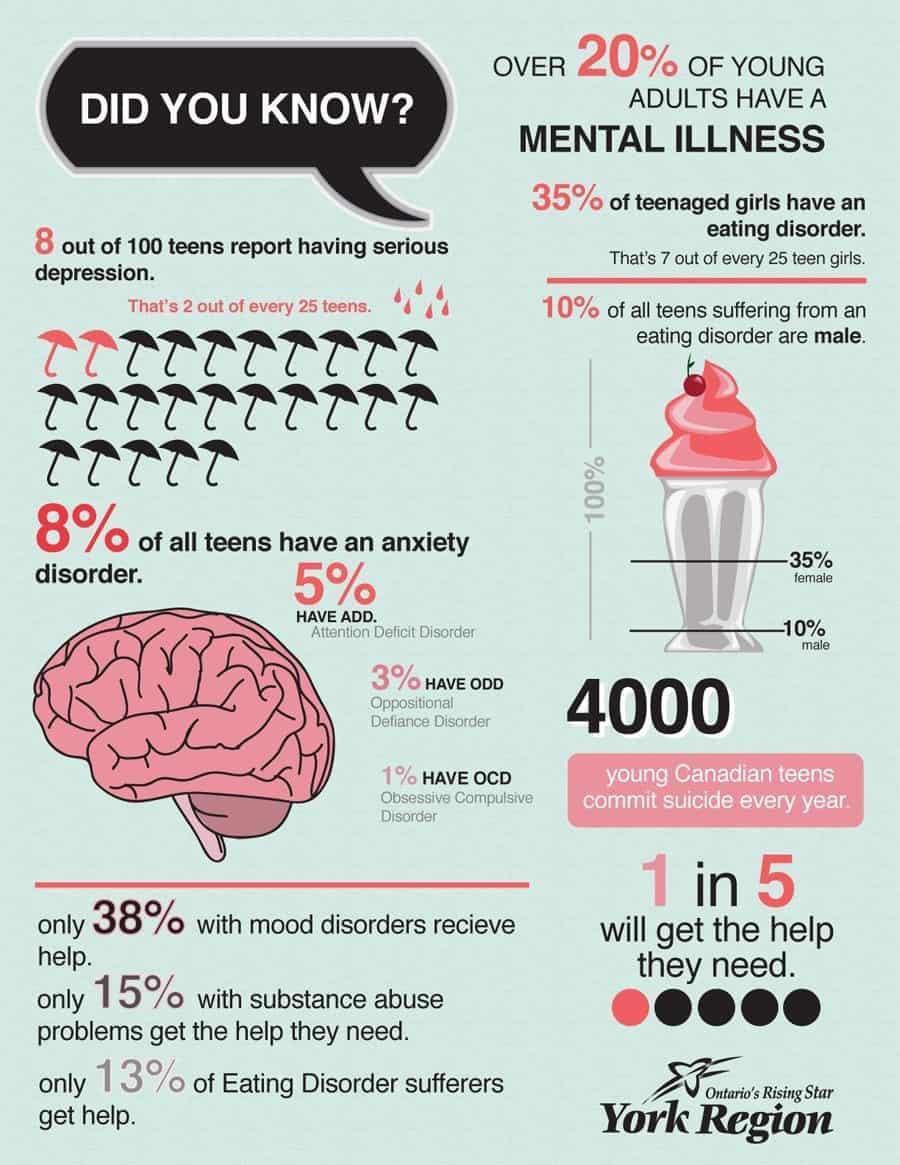who is prone to eating disorder more among teens - girls or boys?
Answer the question with a short phrase. girls how many red umbrellas are there in this infographics? 2 what is the percentage of people with substance abuse problems who do not get help? 85 what is the percentage of people with eating disorder who do not get help? 87 what is the percentage of people with mood disorder who do not get help? 62% What percentage of people does not have OCD? 99% Which is more common, ODD or ADD? ADD What percent of teens suffering from serious depression? 8 how many black umbrellas are there in this infographics? 23 what is the text given inside the black dialogue box? did you know? Which is more common, ODD or OCD? ODD 